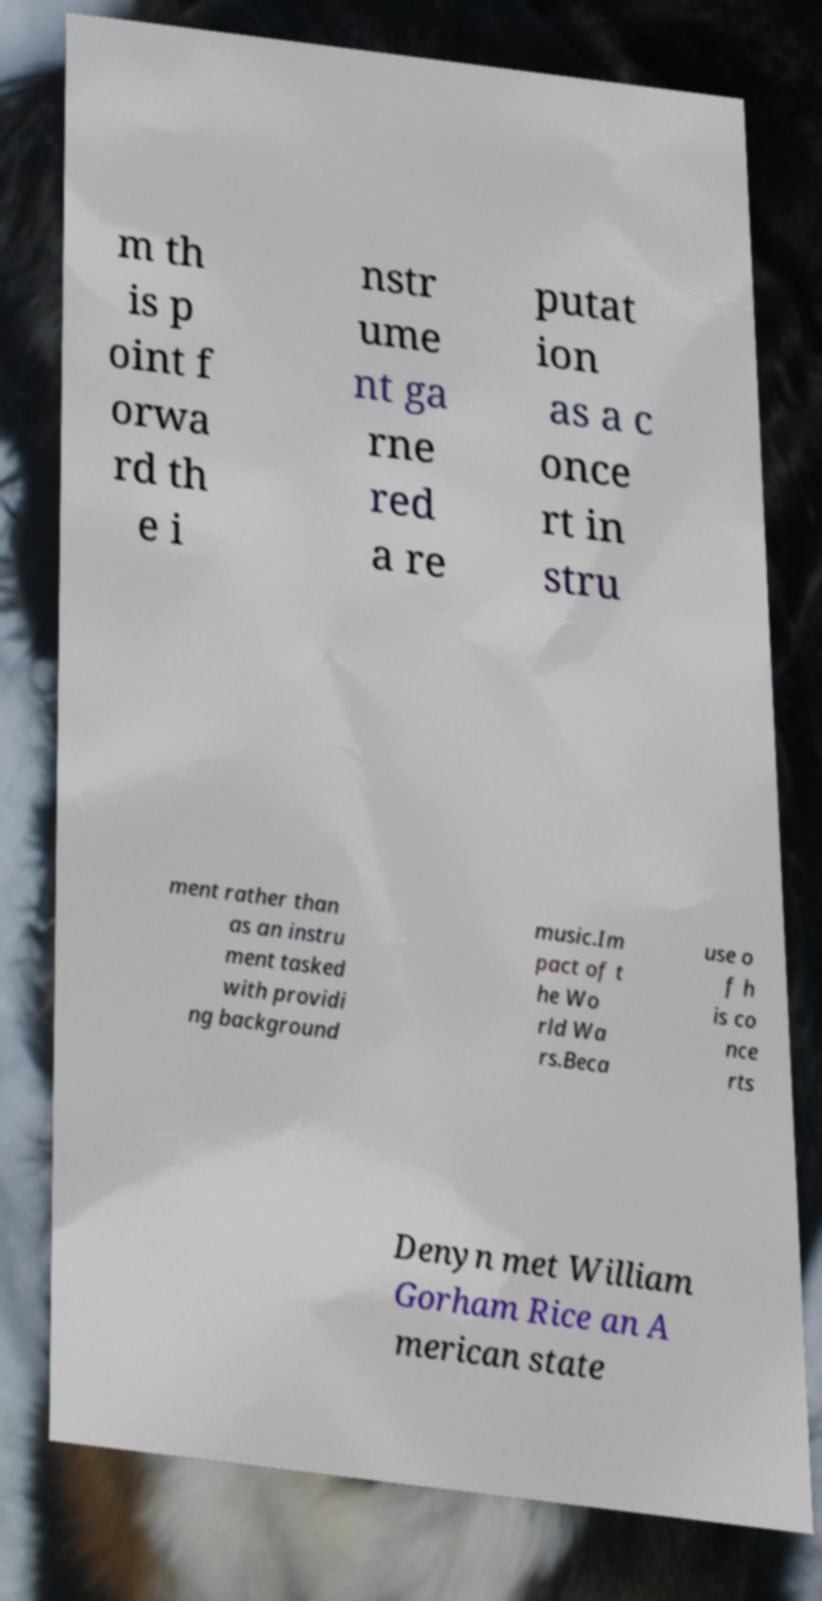Could you extract and type out the text from this image? m th is p oint f orwa rd th e i nstr ume nt ga rne red a re putat ion as a c once rt in stru ment rather than as an instru ment tasked with providi ng background music.Im pact of t he Wo rld Wa rs.Beca use o f h is co nce rts Denyn met William Gorham Rice an A merican state 